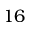<formula> <loc_0><loc_0><loc_500><loc_500>1 6</formula> 